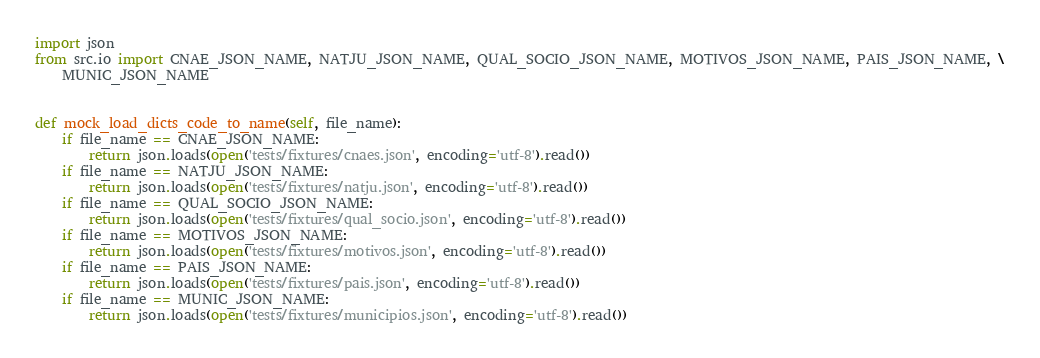Convert code to text. <code><loc_0><loc_0><loc_500><loc_500><_Python_>import json
from src.io import CNAE_JSON_NAME, NATJU_JSON_NAME, QUAL_SOCIO_JSON_NAME, MOTIVOS_JSON_NAME, PAIS_JSON_NAME, \
    MUNIC_JSON_NAME


def mock_load_dicts_code_to_name(self, file_name):
    if file_name == CNAE_JSON_NAME:
        return json.loads(open('tests/fixtures/cnaes.json', encoding='utf-8').read())
    if file_name == NATJU_JSON_NAME:
        return json.loads(open('tests/fixtures/natju.json', encoding='utf-8').read())
    if file_name == QUAL_SOCIO_JSON_NAME:
        return json.loads(open('tests/fixtures/qual_socio.json', encoding='utf-8').read())
    if file_name == MOTIVOS_JSON_NAME:
        return json.loads(open('tests/fixtures/motivos.json', encoding='utf-8').read())
    if file_name == PAIS_JSON_NAME:
        return json.loads(open('tests/fixtures/pais.json', encoding='utf-8').read())
    if file_name == MUNIC_JSON_NAME:
        return json.loads(open('tests/fixtures/municipios.json', encoding='utf-8').read())
</code> 